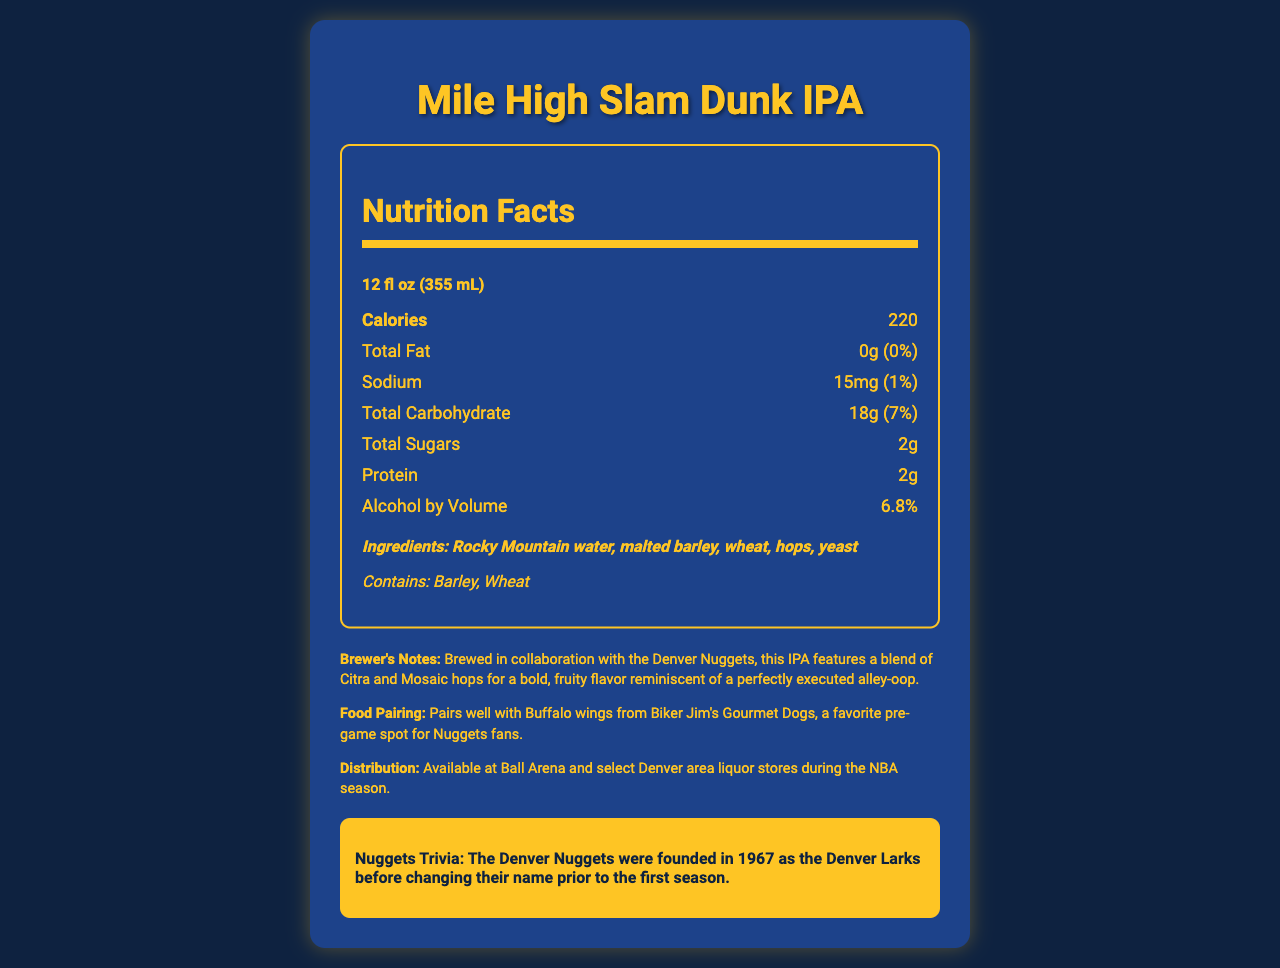who is the brewery collaborating with? The document states that the craft beer is a collaboration between Great Divide Brewing Co. and the Denver Nuggets.
Answer: Denver Nuggets what is the name of the beer? The product name listed in the document is "Mile High Slam Dunk IPA."
Answer: Mile High Slam Dunk IPA how many calories are in one serving? The nutrition facts list 220 calories per 12 fl oz serving.
Answer: 220 what is the alcohol by volume (ABV) percentage? The document specifies the ABV as 6.8%.
Answer: 6.8% which types of hops are used in this IPA? The brewer notes mention that the IPA features a blend of Citra and Mosaic hops.
Answer: Citra and Mosaic hops what is the serving size for this craft beer? The document lists the serving size as 12 fl oz (355 mL).
Answer: 12 fl oz (355 mL) what allergens are present in the beer? The allergen information states that the beer contains barley and wheat.
Answer: Barley, Wheat what does the document suggest pairing this beer with? The food pairing suggestion in the document recommends Buffalo wings from Biker Jim's Gourmet Dogs.
Answer: Buffalo wings from Biker Jim's Gourmet Dogs which nutrient has the highest daily value percentage? A. Sodium B. Total Carbohydrate C. Protein D. Alcohol by Volume Total carbohydrate has a daily value percentage of 7%, which is higher than the other nutrients listed.
Answer: B how much sodium is in one serving? A. 10mg B. 15mg C. 20mg D. 25mg The document lists 15mg of sodium per serving.
Answer: B does this craft beer contain any protein? The document states that there are 2g of protein in the beer.
Answer: Yes is this beer available outside of Denver? The distribution information specifies that the beer is available only at Ball Arena and select Denver area liquor stores during the NBA season.
Answer: No what main idea does the document convey? The document described the nutritional facts, ingredients, allergen information, brewer’s notes, Nuggets trivia, food pairing, and distribution details of the beer.
Answer: The document provides detailed nutritional information, ingredient list, and brewing notes for the Mile High Slam Dunk IPA, a craft beer collaboration between Great Divide Brewing Co. and the Denver Nuggets, including trivia and food pairing suggestions. what year were the Denver Nuggets founded? The Nuggets trivia section mentions that the Denver Nuggets were founded in 1967, initially as the Denver Larks.
Answer: 1967 how much vitamin D is in the beer? The document specifies that there is 0mcg of vitamin D in the beer.
Answer: 0mcg what is the origin of the water used in this IPA? The document lists "Rocky Mountain water" as an ingredient, but it doesn't specify the exact origin or source of this water.
Answer: Not enough information 